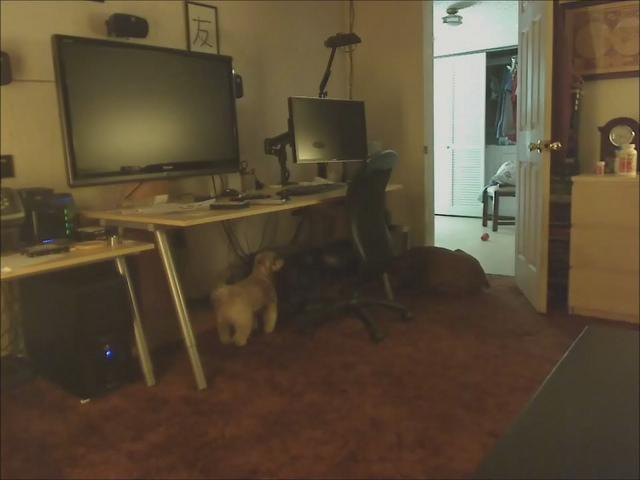How many screens are in the room?
Give a very brief answer. 2. How many chairs are in this room?
Give a very brief answer. 1. How many chairs?
Give a very brief answer. 1. How many pianos are shown?
Give a very brief answer. 0. How many chairs are visible?
Give a very brief answer. 1. How many tvs can be seen?
Give a very brief answer. 2. 